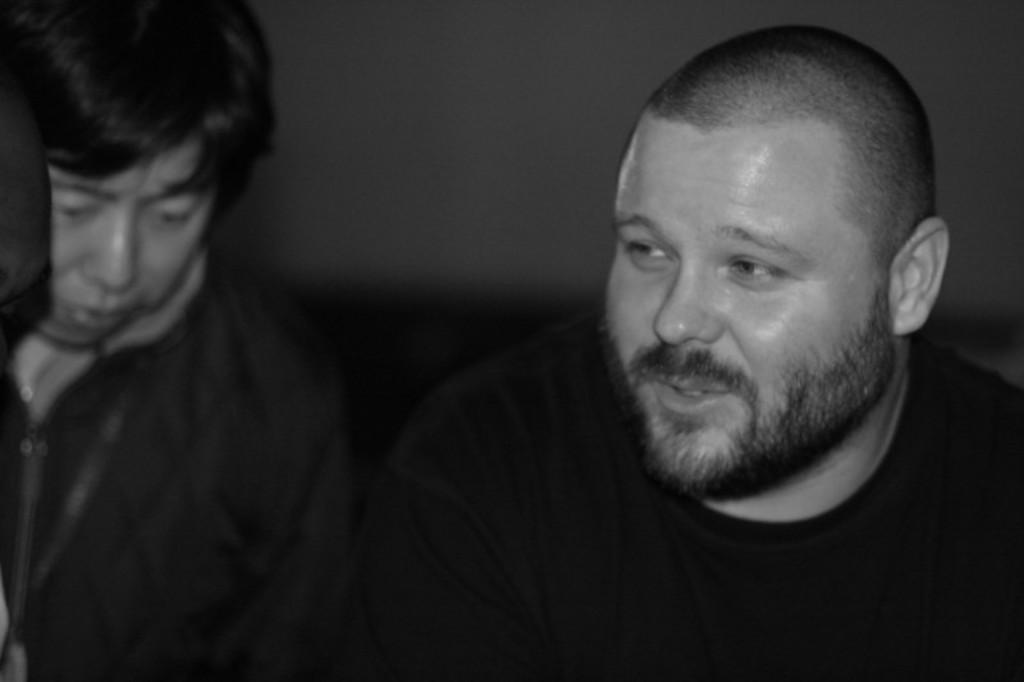Can you describe this image briefly? This is a black and white image in which we can see two people. On the backside we can see a wall. 